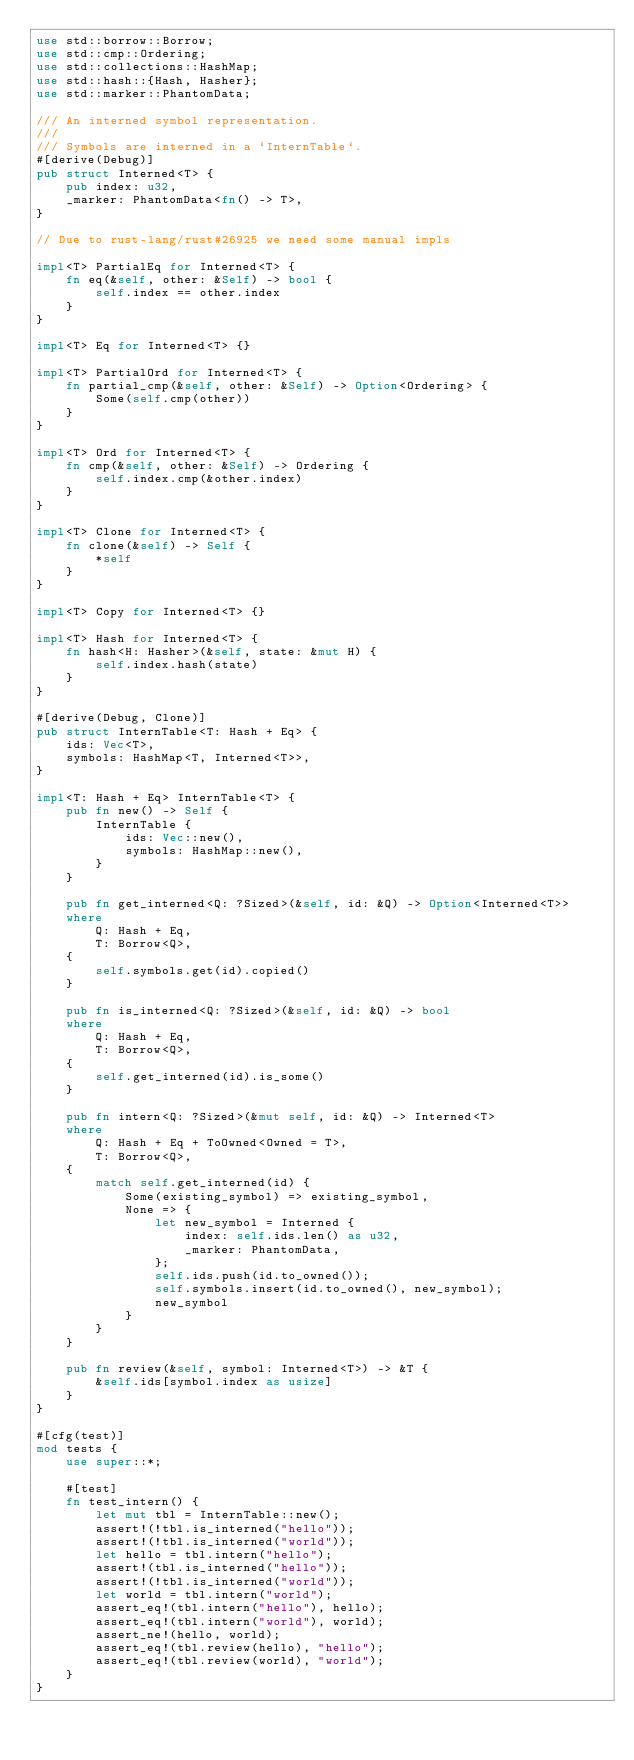Convert code to text. <code><loc_0><loc_0><loc_500><loc_500><_Rust_>use std::borrow::Borrow;
use std::cmp::Ordering;
use std::collections::HashMap;
use std::hash::{Hash, Hasher};
use std::marker::PhantomData;

/// An interned symbol representation.
///
/// Symbols are interned in a `InternTable`.
#[derive(Debug)]
pub struct Interned<T> {
    pub index: u32,
    _marker: PhantomData<fn() -> T>,
}

// Due to rust-lang/rust#26925 we need some manual impls

impl<T> PartialEq for Interned<T> {
    fn eq(&self, other: &Self) -> bool {
        self.index == other.index
    }
}

impl<T> Eq for Interned<T> {}

impl<T> PartialOrd for Interned<T> {
    fn partial_cmp(&self, other: &Self) -> Option<Ordering> {
        Some(self.cmp(other))
    }
}

impl<T> Ord for Interned<T> {
    fn cmp(&self, other: &Self) -> Ordering {
        self.index.cmp(&other.index)
    }
}

impl<T> Clone for Interned<T> {
    fn clone(&self) -> Self {
        *self
    }
}

impl<T> Copy for Interned<T> {}

impl<T> Hash for Interned<T> {
    fn hash<H: Hasher>(&self, state: &mut H) {
        self.index.hash(state)
    }
}

#[derive(Debug, Clone)]
pub struct InternTable<T: Hash + Eq> {
    ids: Vec<T>,
    symbols: HashMap<T, Interned<T>>,
}

impl<T: Hash + Eq> InternTable<T> {
    pub fn new() -> Self {
        InternTable {
            ids: Vec::new(),
            symbols: HashMap::new(),
        }
    }

    pub fn get_interned<Q: ?Sized>(&self, id: &Q) -> Option<Interned<T>>
    where
        Q: Hash + Eq,
        T: Borrow<Q>,
    {
        self.symbols.get(id).copied()
    }

    pub fn is_interned<Q: ?Sized>(&self, id: &Q) -> bool
    where
        Q: Hash + Eq,
        T: Borrow<Q>,
    {
        self.get_interned(id).is_some()
    }

    pub fn intern<Q: ?Sized>(&mut self, id: &Q) -> Interned<T>
    where
        Q: Hash + Eq + ToOwned<Owned = T>,
        T: Borrow<Q>,
    {
        match self.get_interned(id) {
            Some(existing_symbol) => existing_symbol,
            None => {
                let new_symbol = Interned {
                    index: self.ids.len() as u32,
                    _marker: PhantomData,
                };
                self.ids.push(id.to_owned());
                self.symbols.insert(id.to_owned(), new_symbol);
                new_symbol
            }
        }
    }

    pub fn review(&self, symbol: Interned<T>) -> &T {
        &self.ids[symbol.index as usize]
    }
}

#[cfg(test)]
mod tests {
    use super::*;

    #[test]
    fn test_intern() {
        let mut tbl = InternTable::new();
        assert!(!tbl.is_interned("hello"));
        assert!(!tbl.is_interned("world"));
        let hello = tbl.intern("hello");
        assert!(tbl.is_interned("hello"));
        assert!(!tbl.is_interned("world"));
        let world = tbl.intern("world");
        assert_eq!(tbl.intern("hello"), hello);
        assert_eq!(tbl.intern("world"), world);
        assert_ne!(hello, world);
        assert_eq!(tbl.review(hello), "hello");
        assert_eq!(tbl.review(world), "world");
    }
}
</code> 